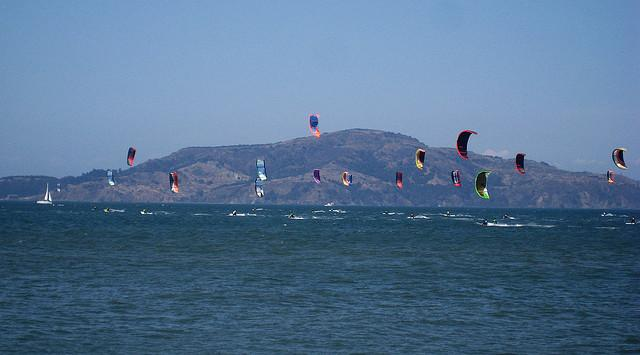Which direction does the wind blow? west 